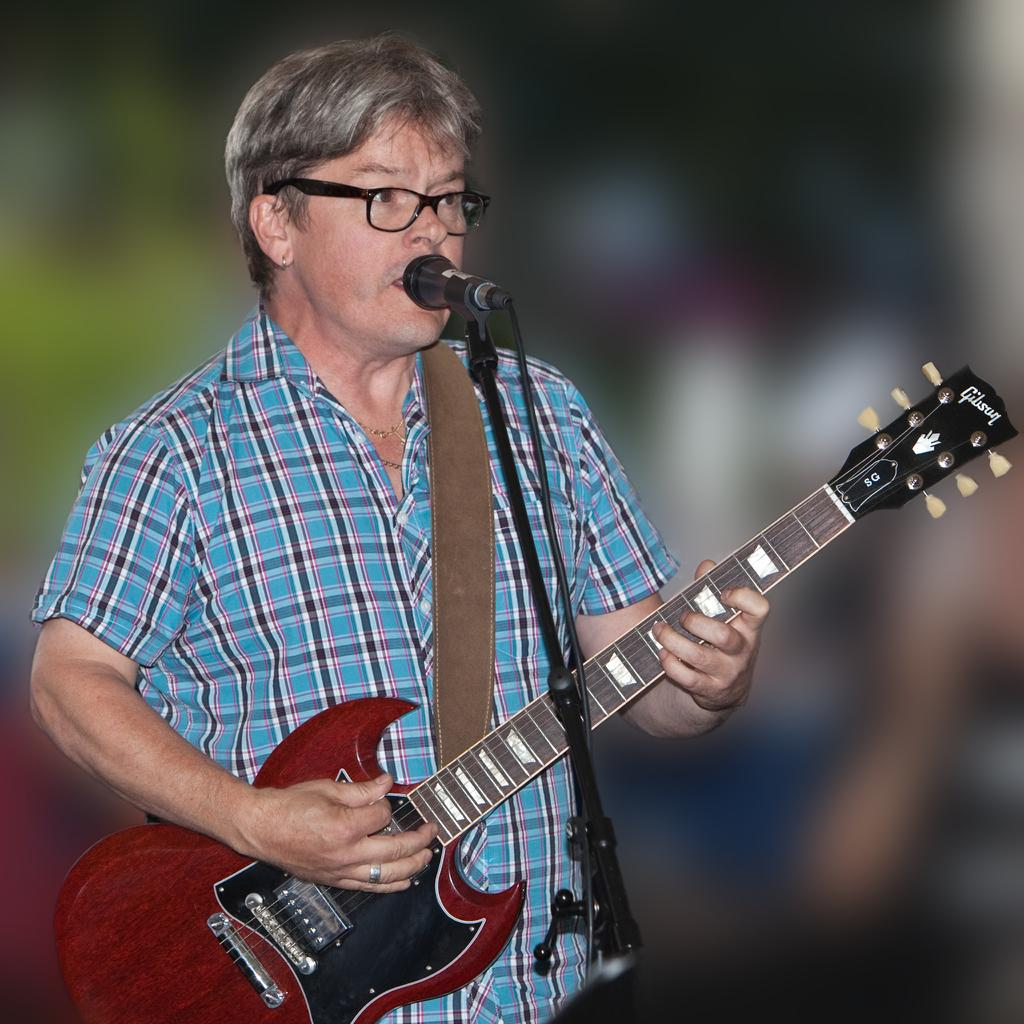What is the main subject of the image? There is a man in the image. What is the man doing in the image? The man is standing, playing the guitar, and singing into a microphone. What type of weather can be seen in the image? There is no weather mentioned or depicted in the image; it focuses on the man and his activities. 